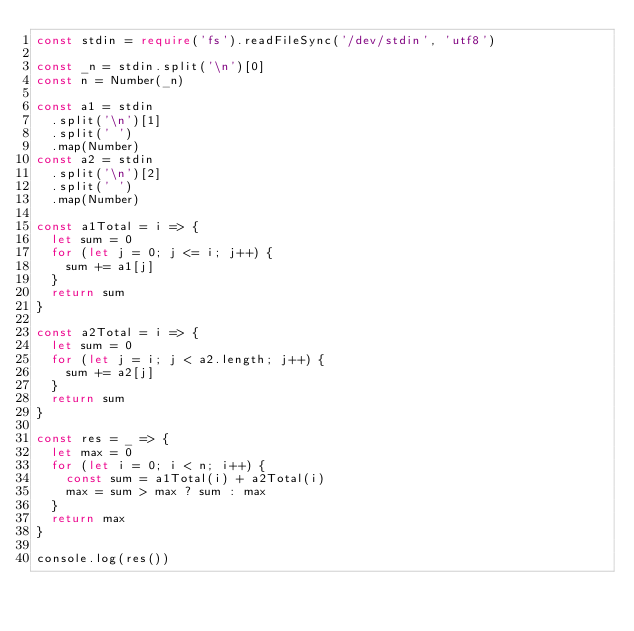<code> <loc_0><loc_0><loc_500><loc_500><_TypeScript_>const stdin = require('fs').readFileSync('/dev/stdin', 'utf8')

const _n = stdin.split('\n')[0]
const n = Number(_n)

const a1 = stdin
  .split('\n')[1]
  .split(' ')
  .map(Number)
const a2 = stdin
  .split('\n')[2]
  .split(' ')
  .map(Number)

const a1Total = i => {
  let sum = 0
  for (let j = 0; j <= i; j++) {
    sum += a1[j]
  }
  return sum
}

const a2Total = i => {
  let sum = 0
  for (let j = i; j < a2.length; j++) {
    sum += a2[j]
  }
  return sum
}

const res = _ => {
  let max = 0
  for (let i = 0; i < n; i++) {
    const sum = a1Total(i) + a2Total(i)
    max = sum > max ? sum : max
  }
  return max
}

console.log(res())
</code> 